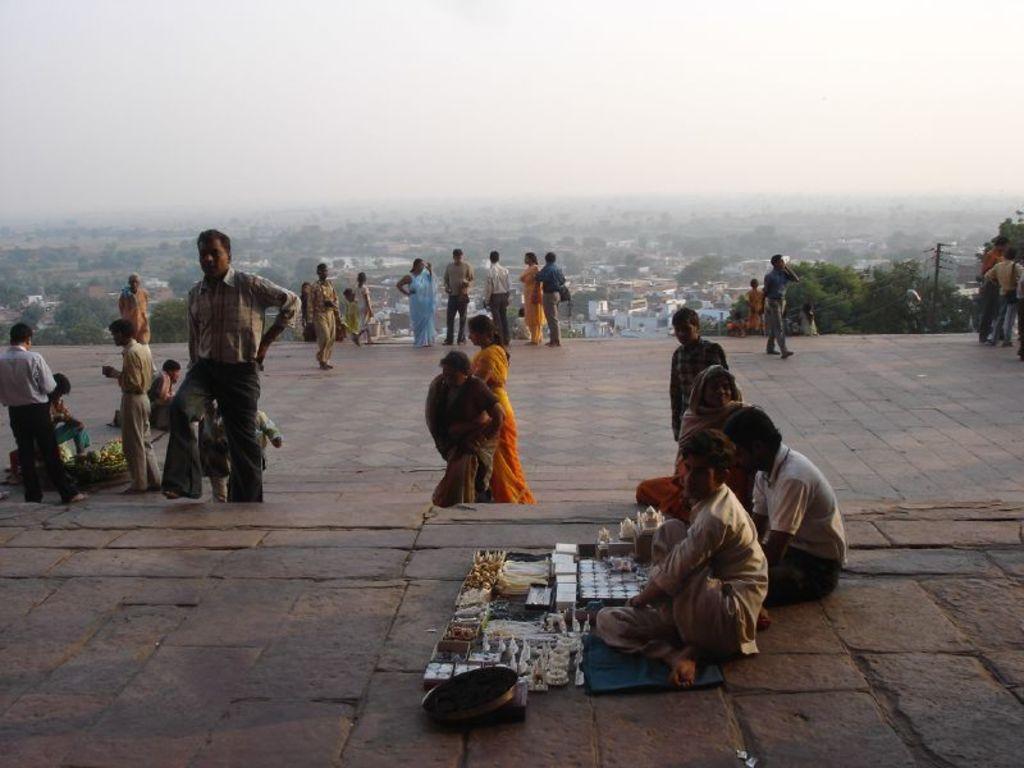In one or two sentences, can you explain what this image depicts? In the picture we can see a path on the hill with full of tiles on it and on it we can see some people are sitting and some people are standing and one man is selling something is sitting on the path and near the edge of the path we can see some people are standing, behind them we can see a pole with wires to it and behind it we can see some trees and behind it we can see houses, trees and behind it we can see a sky. 